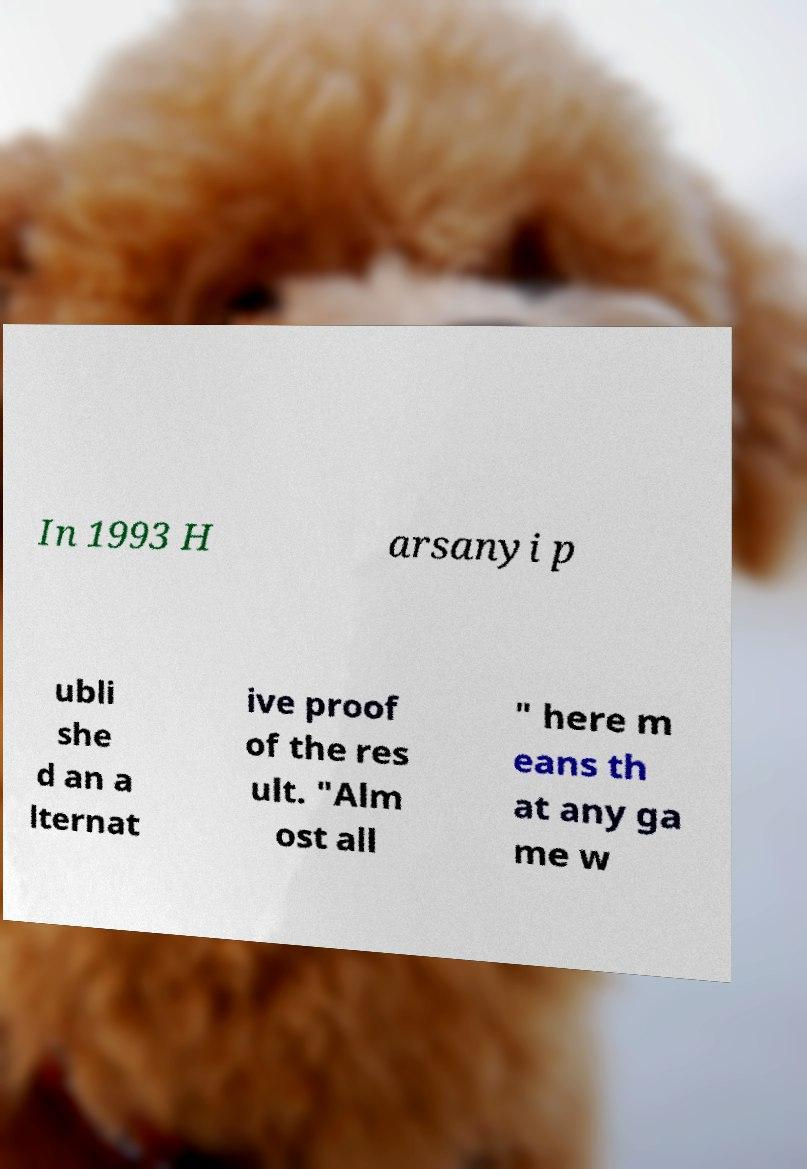Can you read and provide the text displayed in the image?This photo seems to have some interesting text. Can you extract and type it out for me? In 1993 H arsanyi p ubli she d an a lternat ive proof of the res ult. "Alm ost all " here m eans th at any ga me w 